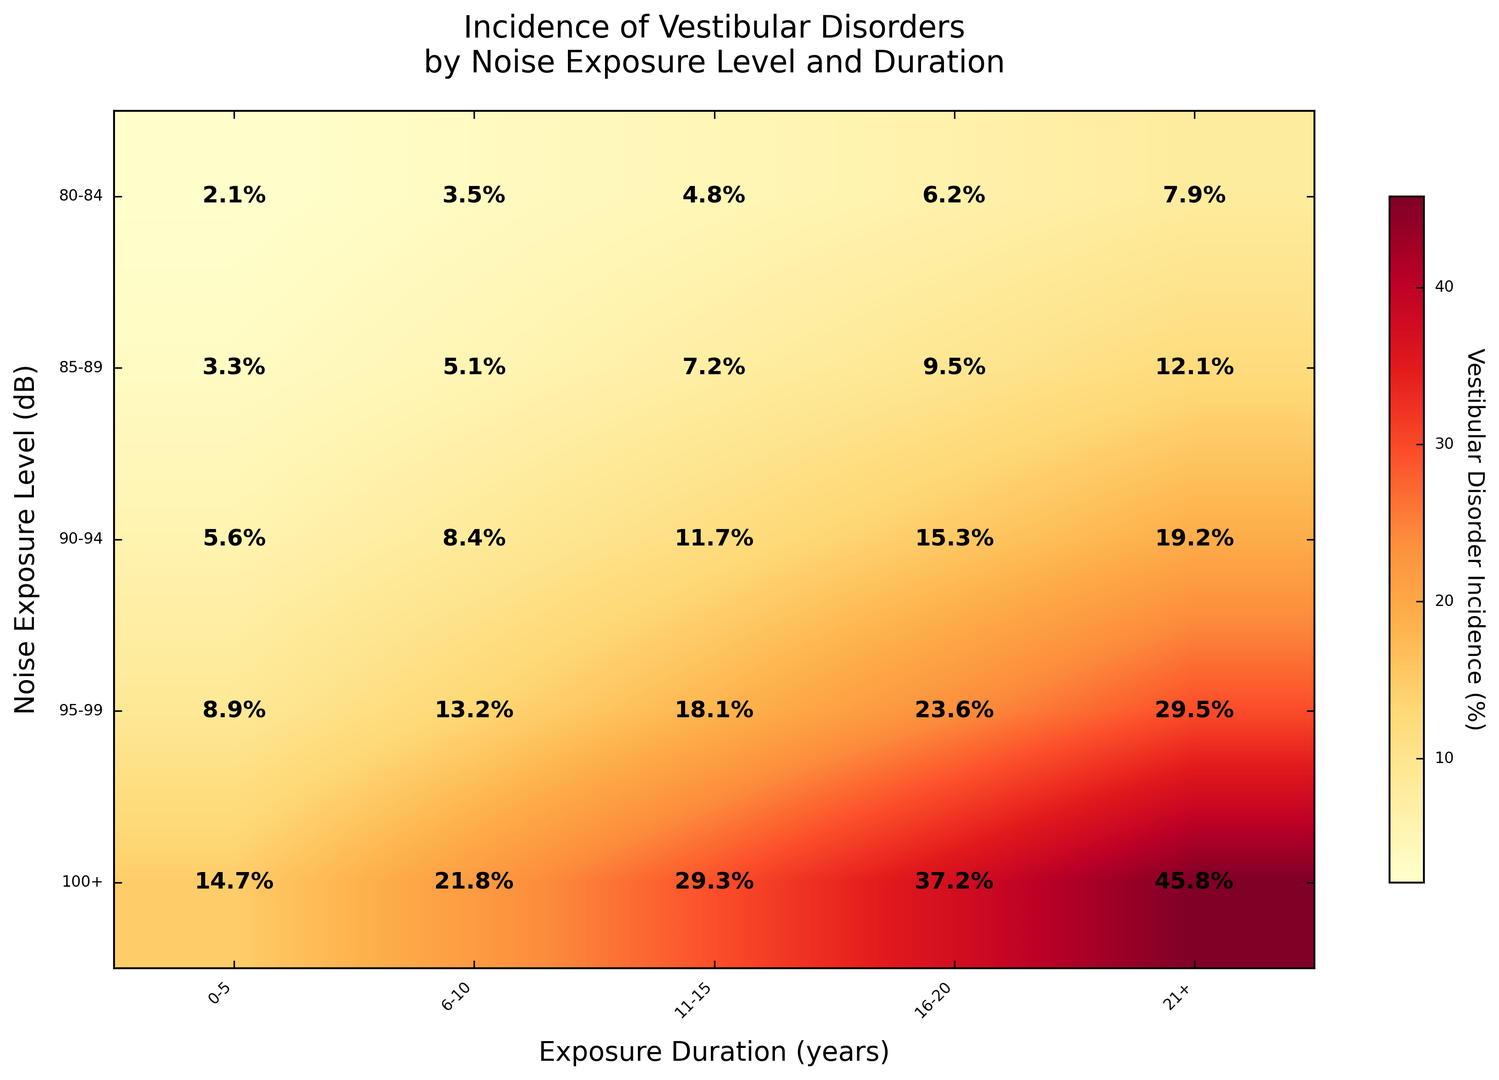What is the incidence of vestibular disorders for exposure levels of 80-84 dB for over 21 years? Locate the cell at the intersection of the 80-84 dB row and the 21+ years column. The value in this cell represents the vestibular disorder incidence.
Answer: 7.9% Which noise exposure level has the highest vestibular disorder incidence for the 0-5 years duration? Look at the first column (0-5 years) and identify the highest value among all the rows. The row corresponding to this value indicates the noise exposure level.
Answer: 100+ Does the incidence of vestibular disorders increase as noise exposure duration increases for the 90-94 dB level? Examine the row corresponding to the 90-94 dB level and verify if the values generally increase as you move from left (0-5 years) to right (21+ years).
Answer: Yes What is the average incidence of vestibular disorders for exposure levels above 90 dB across all durations? Add up all values in the rows for 90-94 dB, 95-99 dB, and 100+ dB and divide by the number of values (15 in total).
Answer: (5.6 + 8.4 + 11.7 + 15.3 + 19.2 + 8.9 + 13.2 + 18.1 + 23.6 + 29.5 + 14.7 + 21.8 + 29.3 + 37.2 + 45.8) / 15 = 20.08% Compare the vestibular disorder incidence between 85-89 dB at 6-10 years and 100+ dB at 16-20 years. Which is higher and by how much? Locate the respective values (5.1% for 85-89 dB at 6-10 years and 37.2% for 100+ dB at 16-20 years), then subtract the smaller value from the larger value to determine the difference.
Answer: 37.2% is higher by 32.1% For noise levels of 95-99 dB, which exposure duration shows the lowest incidence of vestibular disorders? Look at the row for 95-99 dB and identify the column with the lowest value. This value corresponds to the exposure duration with the lowest incidence.
Answer: 0-5 years Is there any instance of vestibular disorder incidence being less than 3%? Check all cells to see if any value is below 3%.
Answer: Yes (80-84 dB at 0-5 years) What is the difference in vestibular disorder incidence between the shortest and longest exposure durations for 85-89 dB? Find the values for 85-89 dB at 0-5 years and 21+ years, then subtract the smaller value from the larger value.
Answer: 12.1% - 3.3% = 8.8% 